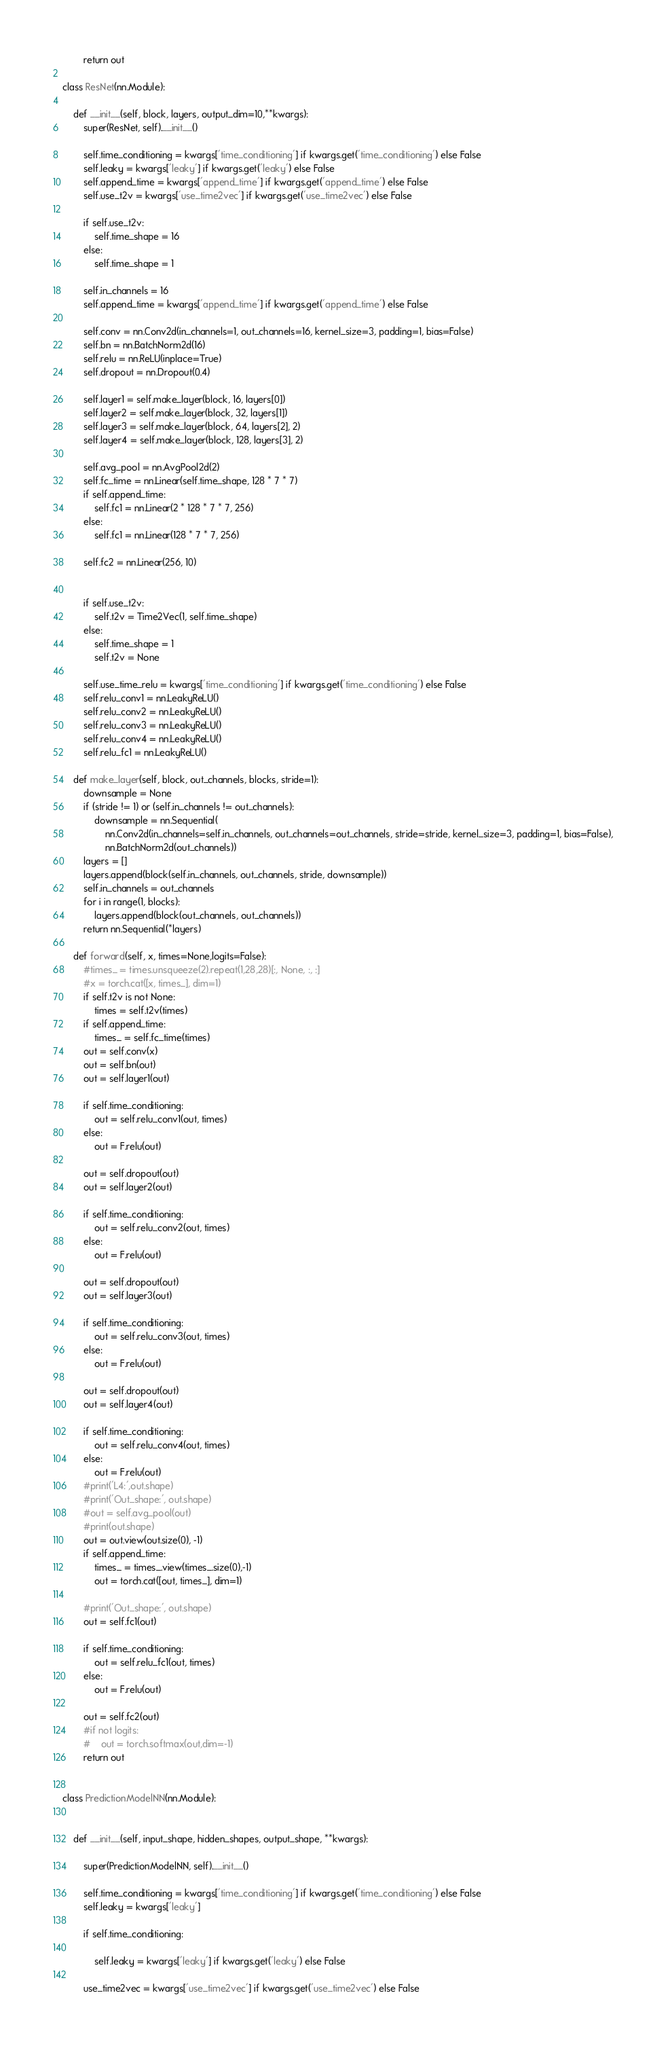<code> <loc_0><loc_0><loc_500><loc_500><_Python_>        return out

class ResNet(nn.Module):

    def __init__(self, block, layers, output_dim=10,**kwargs):
        super(ResNet, self).__init__()

        self.time_conditioning = kwargs['time_conditioning'] if kwargs.get('time_conditioning') else False
        self.leaky = kwargs['leaky'] if kwargs.get('leaky') else False
        self.append_time = kwargs['append_time'] if kwargs.get('append_time') else False
        self.use_t2v = kwargs['use_time2vec'] if kwargs.get('use_time2vec') else False

        if self.use_t2v:
            self.time_shape = 16
        else:
            self.time_shape = 1

        self.in_channels = 16
        self.append_time = kwargs['append_time'] if kwargs.get('append_time') else False

        self.conv = nn.Conv2d(in_channels=1, out_channels=16, kernel_size=3, padding=1, bias=False)
        self.bn = nn.BatchNorm2d(16)
        self.relu = nn.ReLU(inplace=True)
        self.dropout = nn.Dropout(0.4)
        
        self.layer1 = self.make_layer(block, 16, layers[0])
        self.layer2 = self.make_layer(block, 32, layers[1])
        self.layer3 = self.make_layer(block, 64, layers[2], 2)
        self.layer4 = self.make_layer(block, 128, layers[3], 2)
        
        self.avg_pool = nn.AvgPool2d(2)
        self.fc_time = nn.Linear(self.time_shape, 128 * 7 * 7)
        if self.append_time:
            self.fc1 = nn.Linear(2 * 128 * 7 * 7, 256)
        else:
            self.fc1 = nn.Linear(128 * 7 * 7, 256)

        self.fc2 = nn.Linear(256, 10)
        

        if self.use_t2v:
            self.t2v = Time2Vec(1, self.time_shape)
        else:
            self.time_shape = 1
            self.t2v = None
        
        self.use_time_relu = kwargs['time_conditioning'] if kwargs.get('time_conditioning') else False
        self.relu_conv1 = nn.LeakyReLU()
        self.relu_conv2 = nn.LeakyReLU()
        self.relu_conv3 = nn.LeakyReLU()
        self.relu_conv4 = nn.LeakyReLU()
        self.relu_fc1 = nn.LeakyReLU()

    def make_layer(self, block, out_channels, blocks, stride=1):
        downsample = None
        if (stride != 1) or (self.in_channels != out_channels):
            downsample = nn.Sequential(
                nn.Conv2d(in_channels=self.in_channels, out_channels=out_channels, stride=stride, kernel_size=3, padding=1, bias=False),
                nn.BatchNorm2d(out_channels))
        layers = []
        layers.append(block(self.in_channels, out_channels, stride, downsample))
        self.in_channels = out_channels
        for i in range(1, blocks):
            layers.append(block(out_channels, out_channels))
        return nn.Sequential(*layers)

    def forward(self, x, times=None,logits=False):
        #times_ = times.unsqueeze(2).repeat(1,28,28)[:, None, :, :]
        #x = torch.cat([x, times_], dim=1)
        if self.t2v is not None:
            times = self.t2v(times)
        if self.append_time:
            times_ = self.fc_time(times)
        out = self.conv(x)
        out = self.bn(out)
        out = self.layer1(out)
        
        if self.time_conditioning:
            out = self.relu_conv1(out, times)
        else:
            out = F.relu(out)

        out = self.dropout(out)
        out = self.layer2(out)

        if self.time_conditioning:
            out = self.relu_conv2(out, times)
        else:
            out = F.relu(out)

        out = self.dropout(out)
        out = self.layer3(out)

        if self.time_conditioning:
            out = self.relu_conv3(out, times)
        else:
            out = F.relu(out)
        
        out = self.dropout(out)
        out = self.layer4(out)
        
        if self.time_conditioning:
            out = self.relu_conv4(out, times)
        else:
            out = F.relu(out)
        #print('L4:',out.shape)
        #print('Out_shape:', out.shape)
        #out = self.avg_pool(out)
        #print(out.shape)
        out = out.view(out.size(0), -1)
        if self.append_time:
            times_ = times_.view(times_.size(0),-1)
            out = torch.cat([out, times_], dim=1)

        #print('Out_shape:', out.shape)
        out = self.fc1(out)

        if self.time_conditioning:
            out = self.relu_fc1(out, times)
        else:
            out = F.relu(out)

        out = self.fc2(out)
        #if not logits:
        #    out = torch.softmax(out,dim=-1)
        return out


class PredictionModelNN(nn.Module):

    
    def __init__(self, input_shape, hidden_shapes, output_shape, **kwargs):
        
        super(PredictionModelNN, self).__init__()

        self.time_conditioning = kwargs['time_conditioning'] if kwargs.get('time_conditioning') else False
        self.leaky = kwargs['leaky']
        
        if self.time_conditioning:

            self.leaky = kwargs['leaky'] if kwargs.get('leaky') else False
            
        use_time2vec = kwargs['use_time2vec'] if kwargs.get('use_time2vec') else False</code> 